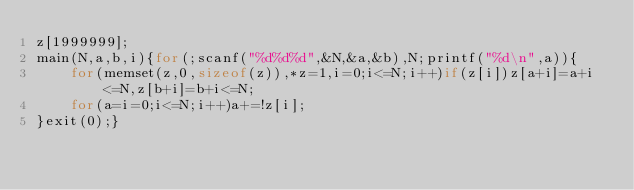Convert code to text. <code><loc_0><loc_0><loc_500><loc_500><_C_>z[1999999];
main(N,a,b,i){for(;scanf("%d%d%d",&N,&a,&b),N;printf("%d\n",a)){
	for(memset(z,0,sizeof(z)),*z=1,i=0;i<=N;i++)if(z[i])z[a+i]=a+i<=N,z[b+i]=b+i<=N;
	for(a=i=0;i<=N;i++)a+=!z[i];
}exit(0);}</code> 